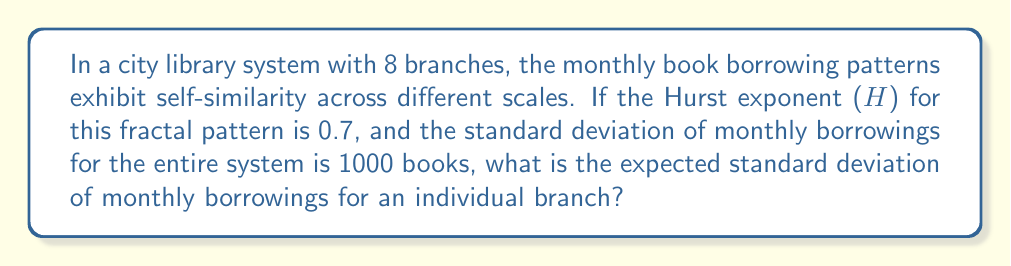Can you solve this math problem? To solve this problem, we'll use concepts from fractal analysis and the properties of self-similar systems:

1. The Hurst exponent (H) describes the degree of self-similarity in a system. For fractal time series, it's related to the fractal dimension (D) by the equation:

   $$ D = 2 - H $$

2. In this case, $H = 0.7$, so the fractal dimension is:

   $$ D = 2 - 0.7 = 1.3 $$

3. For self-similar systems, the relationship between the standard deviation at different scales follows the power law:

   $$ \frac{\sigma_2}{\sigma_1} = \left(\frac{N_1}{N_2}\right)^H $$

   Where $\sigma_1$ and $\sigma_2$ are the standard deviations at scales $N_1$ and $N_2$ respectively.

4. In our case:
   - $\sigma_1 = 1000$ (standard deviation for the entire system)
   - $N_1 = 8$ (total number of branches)
   - $N_2 = 1$ (individual branch)
   - $H = 0.7$ (given Hurst exponent)

5. Substituting these values into the equation:

   $$ \frac{\sigma_2}{1000} = \left(\frac{8}{1}\right)^{0.7} $$

6. Simplifying:

   $$ \frac{\sigma_2}{1000} = 8^{0.7} \approx 4.0273 $$

7. Solving for $\sigma_2$:

   $$ \sigma_2 = 1000 \cdot 8^{0.7} \approx 4027.3 $$

Therefore, the expected standard deviation of monthly borrowings for an individual branch is approximately 402.73 books.
Answer: 402.73 books 